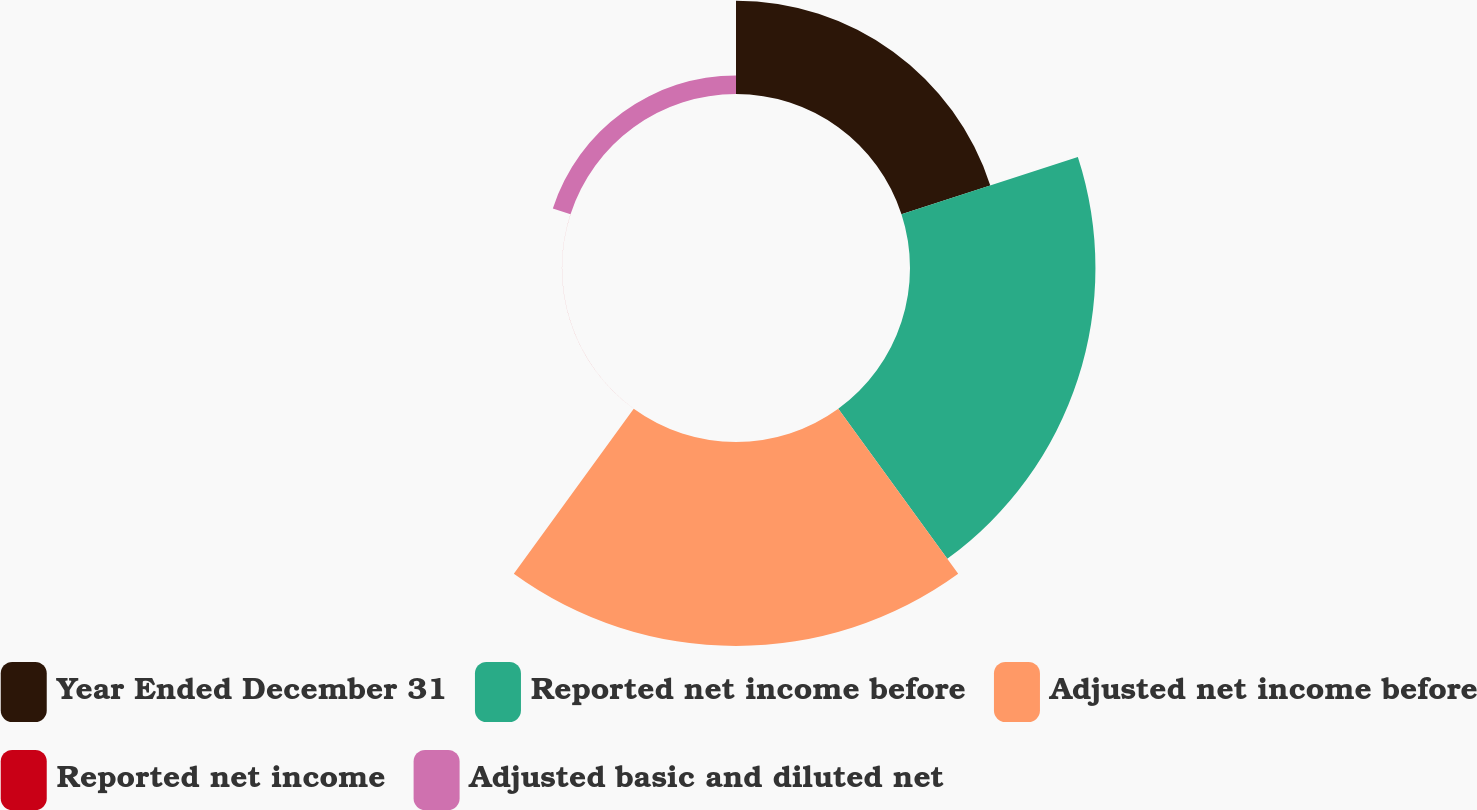Convert chart. <chart><loc_0><loc_0><loc_500><loc_500><pie_chart><fcel>Year Ended December 31<fcel>Reported net income before<fcel>Adjusted net income before<fcel>Reported net income<fcel>Adjusted basic and diluted net<nl><fcel>18.62%<fcel>36.98%<fcel>40.68%<fcel>0.01%<fcel>3.71%<nl></chart> 